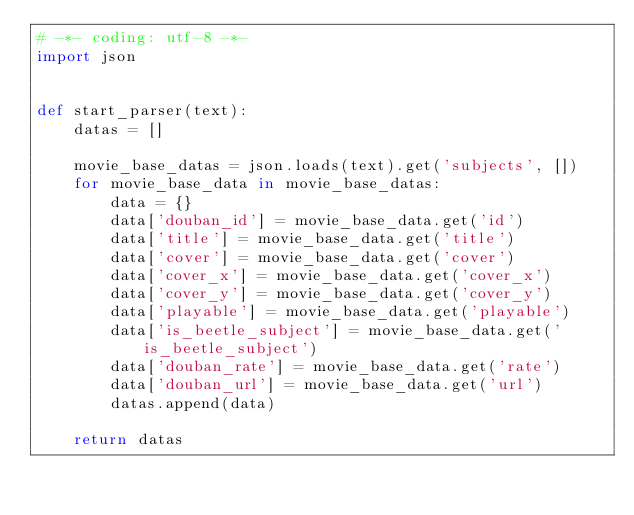<code> <loc_0><loc_0><loc_500><loc_500><_Python_># -*- coding: utf-8 -*-
import json


def start_parser(text):
    datas = []

    movie_base_datas = json.loads(text).get('subjects', [])
    for movie_base_data in movie_base_datas:
        data = {}
        data['douban_id'] = movie_base_data.get('id')
        data['title'] = movie_base_data.get('title')
        data['cover'] = movie_base_data.get('cover')
        data['cover_x'] = movie_base_data.get('cover_x')
        data['cover_y'] = movie_base_data.get('cover_y')
        data['playable'] = movie_base_data.get('playable')
        data['is_beetle_subject'] = movie_base_data.get('is_beetle_subject')
        data['douban_rate'] = movie_base_data.get('rate')
        data['douban_url'] = movie_base_data.get('url')
        datas.append(data)

    return datas
</code> 